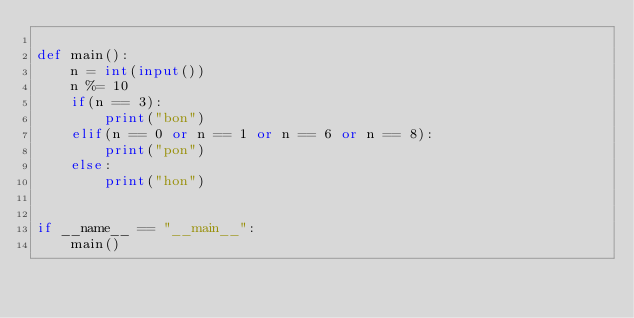Convert code to text. <code><loc_0><loc_0><loc_500><loc_500><_Python_>
def main():
    n = int(input())
    n %= 10
    if(n == 3):
        print("bon")
    elif(n == 0 or n == 1 or n == 6 or n == 8):
        print("pon")
    else:
        print("hon")


if __name__ == "__main__":
    main()</code> 